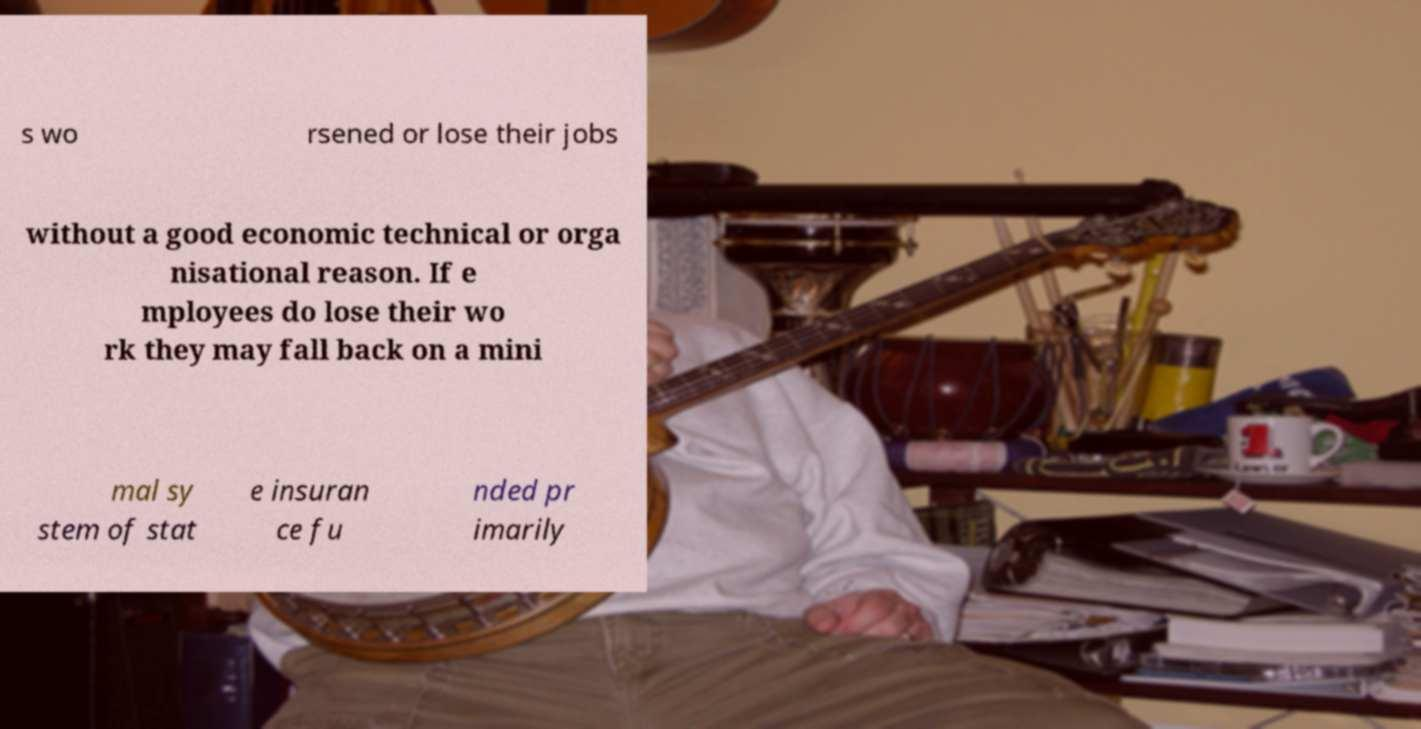What messages or text are displayed in this image? I need them in a readable, typed format. s wo rsened or lose their jobs without a good economic technical or orga nisational reason. If e mployees do lose their wo rk they may fall back on a mini mal sy stem of stat e insuran ce fu nded pr imarily 